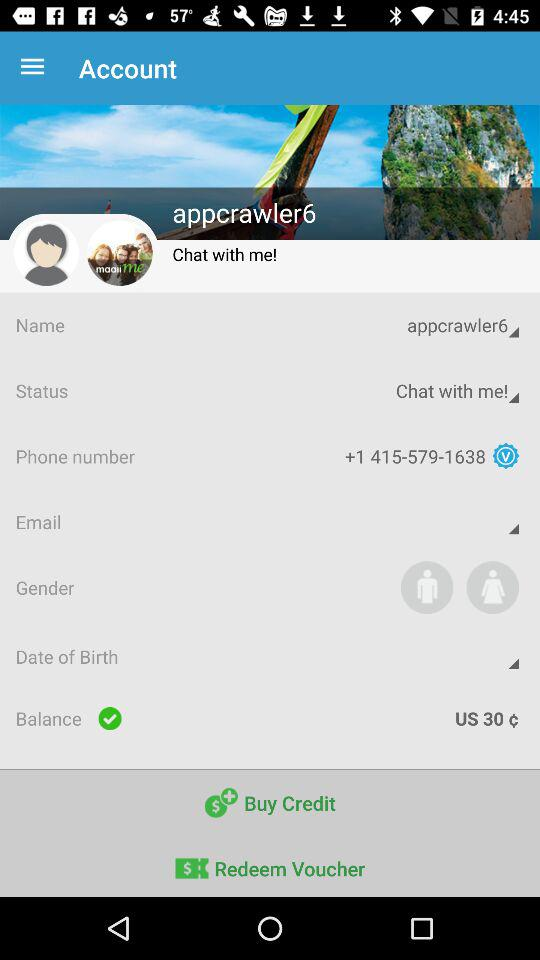What is the status of the balance?
When the provided information is insufficient, respond with <no answer>. <no answer> 